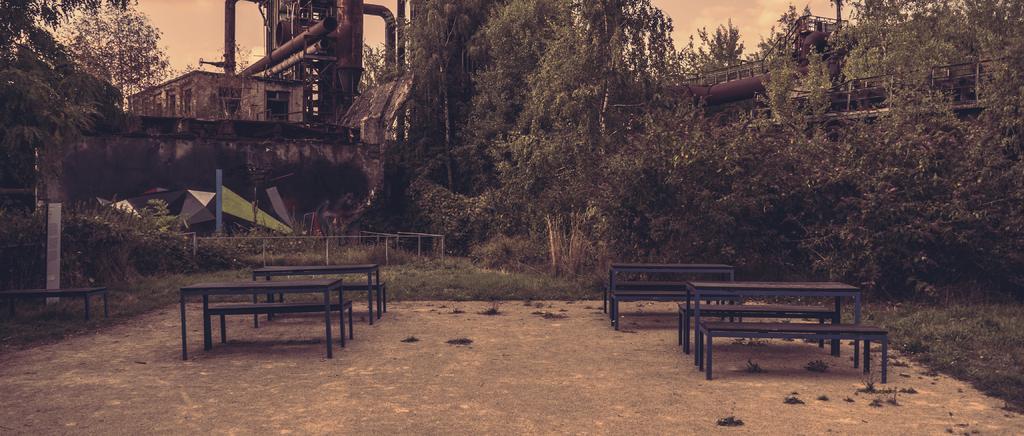Can you describe this image briefly? In this picture we can see tables and benches on the path. We can see grass, trees, railings, pipes, a building, other objects and the sky. 